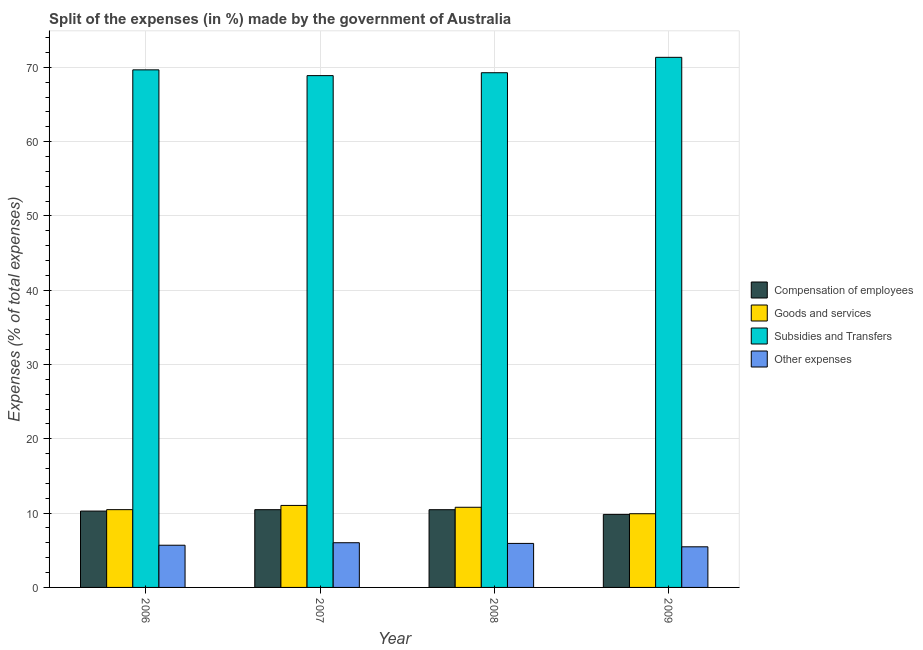How many groups of bars are there?
Offer a very short reply. 4. Are the number of bars per tick equal to the number of legend labels?
Offer a terse response. Yes. How many bars are there on the 2nd tick from the left?
Provide a succinct answer. 4. How many bars are there on the 3rd tick from the right?
Offer a very short reply. 4. In how many cases, is the number of bars for a given year not equal to the number of legend labels?
Your answer should be very brief. 0. What is the percentage of amount spent on subsidies in 2007?
Your answer should be compact. 68.88. Across all years, what is the maximum percentage of amount spent on subsidies?
Keep it short and to the point. 71.34. Across all years, what is the minimum percentage of amount spent on subsidies?
Make the answer very short. 68.88. In which year was the percentage of amount spent on goods and services maximum?
Provide a succinct answer. 2007. What is the total percentage of amount spent on subsidies in the graph?
Your answer should be very brief. 279.14. What is the difference between the percentage of amount spent on compensation of employees in 2007 and that in 2009?
Your response must be concise. 0.64. What is the difference between the percentage of amount spent on goods and services in 2007 and the percentage of amount spent on compensation of employees in 2006?
Your response must be concise. 0.57. What is the average percentage of amount spent on goods and services per year?
Provide a short and direct response. 10.55. What is the ratio of the percentage of amount spent on subsidies in 2007 to that in 2009?
Offer a terse response. 0.97. What is the difference between the highest and the second highest percentage of amount spent on subsidies?
Provide a succinct answer. 1.69. What is the difference between the highest and the lowest percentage of amount spent on goods and services?
Your answer should be compact. 1.12. Is it the case that in every year, the sum of the percentage of amount spent on goods and services and percentage of amount spent on subsidies is greater than the sum of percentage of amount spent on compensation of employees and percentage of amount spent on other expenses?
Make the answer very short. No. What does the 3rd bar from the left in 2006 represents?
Ensure brevity in your answer.  Subsidies and Transfers. What does the 2nd bar from the right in 2009 represents?
Offer a terse response. Subsidies and Transfers. Does the graph contain any zero values?
Give a very brief answer. No. What is the title of the graph?
Offer a very short reply. Split of the expenses (in %) made by the government of Australia. Does "Fourth 20% of population" appear as one of the legend labels in the graph?
Ensure brevity in your answer.  No. What is the label or title of the Y-axis?
Offer a very short reply. Expenses (% of total expenses). What is the Expenses (% of total expenses) in Compensation of employees in 2006?
Make the answer very short. 10.28. What is the Expenses (% of total expenses) of Goods and services in 2006?
Provide a short and direct response. 10.47. What is the Expenses (% of total expenses) in Subsidies and Transfers in 2006?
Provide a short and direct response. 69.65. What is the Expenses (% of total expenses) in Other expenses in 2006?
Provide a succinct answer. 5.68. What is the Expenses (% of total expenses) of Compensation of employees in 2007?
Provide a short and direct response. 10.46. What is the Expenses (% of total expenses) of Goods and services in 2007?
Your answer should be compact. 11.03. What is the Expenses (% of total expenses) of Subsidies and Transfers in 2007?
Your response must be concise. 68.88. What is the Expenses (% of total expenses) in Other expenses in 2007?
Make the answer very short. 6.02. What is the Expenses (% of total expenses) in Compensation of employees in 2008?
Ensure brevity in your answer.  10.46. What is the Expenses (% of total expenses) in Goods and services in 2008?
Provide a short and direct response. 10.79. What is the Expenses (% of total expenses) in Subsidies and Transfers in 2008?
Offer a very short reply. 69.27. What is the Expenses (% of total expenses) of Other expenses in 2008?
Give a very brief answer. 5.92. What is the Expenses (% of total expenses) of Compensation of employees in 2009?
Ensure brevity in your answer.  9.83. What is the Expenses (% of total expenses) in Goods and services in 2009?
Your answer should be compact. 9.92. What is the Expenses (% of total expenses) in Subsidies and Transfers in 2009?
Provide a succinct answer. 71.34. What is the Expenses (% of total expenses) in Other expenses in 2009?
Offer a very short reply. 5.47. Across all years, what is the maximum Expenses (% of total expenses) of Compensation of employees?
Provide a short and direct response. 10.46. Across all years, what is the maximum Expenses (% of total expenses) of Goods and services?
Your answer should be very brief. 11.03. Across all years, what is the maximum Expenses (% of total expenses) of Subsidies and Transfers?
Your answer should be compact. 71.34. Across all years, what is the maximum Expenses (% of total expenses) of Other expenses?
Make the answer very short. 6.02. Across all years, what is the minimum Expenses (% of total expenses) in Compensation of employees?
Make the answer very short. 9.83. Across all years, what is the minimum Expenses (% of total expenses) in Goods and services?
Your answer should be very brief. 9.92. Across all years, what is the minimum Expenses (% of total expenses) in Subsidies and Transfers?
Offer a terse response. 68.88. Across all years, what is the minimum Expenses (% of total expenses) of Other expenses?
Provide a succinct answer. 5.47. What is the total Expenses (% of total expenses) of Compensation of employees in the graph?
Your answer should be compact. 41.03. What is the total Expenses (% of total expenses) of Goods and services in the graph?
Offer a very short reply. 42.21. What is the total Expenses (% of total expenses) of Subsidies and Transfers in the graph?
Offer a terse response. 279.14. What is the total Expenses (% of total expenses) in Other expenses in the graph?
Your answer should be very brief. 23.08. What is the difference between the Expenses (% of total expenses) in Compensation of employees in 2006 and that in 2007?
Your response must be concise. -0.19. What is the difference between the Expenses (% of total expenses) of Goods and services in 2006 and that in 2007?
Your answer should be very brief. -0.57. What is the difference between the Expenses (% of total expenses) in Subsidies and Transfers in 2006 and that in 2007?
Give a very brief answer. 0.78. What is the difference between the Expenses (% of total expenses) of Other expenses in 2006 and that in 2007?
Your answer should be compact. -0.34. What is the difference between the Expenses (% of total expenses) of Compensation of employees in 2006 and that in 2008?
Make the answer very short. -0.19. What is the difference between the Expenses (% of total expenses) of Goods and services in 2006 and that in 2008?
Keep it short and to the point. -0.32. What is the difference between the Expenses (% of total expenses) of Subsidies and Transfers in 2006 and that in 2008?
Offer a very short reply. 0.39. What is the difference between the Expenses (% of total expenses) of Other expenses in 2006 and that in 2008?
Ensure brevity in your answer.  -0.24. What is the difference between the Expenses (% of total expenses) in Compensation of employees in 2006 and that in 2009?
Provide a succinct answer. 0.45. What is the difference between the Expenses (% of total expenses) in Goods and services in 2006 and that in 2009?
Your answer should be compact. 0.55. What is the difference between the Expenses (% of total expenses) in Subsidies and Transfers in 2006 and that in 2009?
Your answer should be very brief. -1.69. What is the difference between the Expenses (% of total expenses) of Other expenses in 2006 and that in 2009?
Offer a terse response. 0.21. What is the difference between the Expenses (% of total expenses) in Compensation of employees in 2007 and that in 2008?
Provide a succinct answer. 0. What is the difference between the Expenses (% of total expenses) of Goods and services in 2007 and that in 2008?
Give a very brief answer. 0.25. What is the difference between the Expenses (% of total expenses) of Subsidies and Transfers in 2007 and that in 2008?
Make the answer very short. -0.39. What is the difference between the Expenses (% of total expenses) in Other expenses in 2007 and that in 2008?
Offer a terse response. 0.09. What is the difference between the Expenses (% of total expenses) of Compensation of employees in 2007 and that in 2009?
Ensure brevity in your answer.  0.64. What is the difference between the Expenses (% of total expenses) in Goods and services in 2007 and that in 2009?
Your answer should be very brief. 1.12. What is the difference between the Expenses (% of total expenses) in Subsidies and Transfers in 2007 and that in 2009?
Provide a short and direct response. -2.46. What is the difference between the Expenses (% of total expenses) of Other expenses in 2007 and that in 2009?
Your response must be concise. 0.55. What is the difference between the Expenses (% of total expenses) of Compensation of employees in 2008 and that in 2009?
Give a very brief answer. 0.63. What is the difference between the Expenses (% of total expenses) of Goods and services in 2008 and that in 2009?
Give a very brief answer. 0.87. What is the difference between the Expenses (% of total expenses) of Subsidies and Transfers in 2008 and that in 2009?
Offer a very short reply. -2.07. What is the difference between the Expenses (% of total expenses) of Other expenses in 2008 and that in 2009?
Keep it short and to the point. 0.46. What is the difference between the Expenses (% of total expenses) of Compensation of employees in 2006 and the Expenses (% of total expenses) of Goods and services in 2007?
Your response must be concise. -0.76. What is the difference between the Expenses (% of total expenses) in Compensation of employees in 2006 and the Expenses (% of total expenses) in Subsidies and Transfers in 2007?
Your answer should be compact. -58.6. What is the difference between the Expenses (% of total expenses) in Compensation of employees in 2006 and the Expenses (% of total expenses) in Other expenses in 2007?
Keep it short and to the point. 4.26. What is the difference between the Expenses (% of total expenses) in Goods and services in 2006 and the Expenses (% of total expenses) in Subsidies and Transfers in 2007?
Your response must be concise. -58.41. What is the difference between the Expenses (% of total expenses) in Goods and services in 2006 and the Expenses (% of total expenses) in Other expenses in 2007?
Offer a terse response. 4.45. What is the difference between the Expenses (% of total expenses) in Subsidies and Transfers in 2006 and the Expenses (% of total expenses) in Other expenses in 2007?
Your response must be concise. 63.64. What is the difference between the Expenses (% of total expenses) of Compensation of employees in 2006 and the Expenses (% of total expenses) of Goods and services in 2008?
Keep it short and to the point. -0.51. What is the difference between the Expenses (% of total expenses) of Compensation of employees in 2006 and the Expenses (% of total expenses) of Subsidies and Transfers in 2008?
Ensure brevity in your answer.  -58.99. What is the difference between the Expenses (% of total expenses) in Compensation of employees in 2006 and the Expenses (% of total expenses) in Other expenses in 2008?
Provide a succinct answer. 4.35. What is the difference between the Expenses (% of total expenses) in Goods and services in 2006 and the Expenses (% of total expenses) in Subsidies and Transfers in 2008?
Your answer should be compact. -58.8. What is the difference between the Expenses (% of total expenses) in Goods and services in 2006 and the Expenses (% of total expenses) in Other expenses in 2008?
Offer a terse response. 4.54. What is the difference between the Expenses (% of total expenses) in Subsidies and Transfers in 2006 and the Expenses (% of total expenses) in Other expenses in 2008?
Ensure brevity in your answer.  63.73. What is the difference between the Expenses (% of total expenses) of Compensation of employees in 2006 and the Expenses (% of total expenses) of Goods and services in 2009?
Ensure brevity in your answer.  0.36. What is the difference between the Expenses (% of total expenses) in Compensation of employees in 2006 and the Expenses (% of total expenses) in Subsidies and Transfers in 2009?
Make the answer very short. -61.06. What is the difference between the Expenses (% of total expenses) in Compensation of employees in 2006 and the Expenses (% of total expenses) in Other expenses in 2009?
Offer a very short reply. 4.81. What is the difference between the Expenses (% of total expenses) of Goods and services in 2006 and the Expenses (% of total expenses) of Subsidies and Transfers in 2009?
Ensure brevity in your answer.  -60.87. What is the difference between the Expenses (% of total expenses) of Goods and services in 2006 and the Expenses (% of total expenses) of Other expenses in 2009?
Ensure brevity in your answer.  5. What is the difference between the Expenses (% of total expenses) of Subsidies and Transfers in 2006 and the Expenses (% of total expenses) of Other expenses in 2009?
Your answer should be very brief. 64.19. What is the difference between the Expenses (% of total expenses) in Compensation of employees in 2007 and the Expenses (% of total expenses) in Goods and services in 2008?
Provide a short and direct response. -0.32. What is the difference between the Expenses (% of total expenses) of Compensation of employees in 2007 and the Expenses (% of total expenses) of Subsidies and Transfers in 2008?
Offer a terse response. -58.8. What is the difference between the Expenses (% of total expenses) in Compensation of employees in 2007 and the Expenses (% of total expenses) in Other expenses in 2008?
Ensure brevity in your answer.  4.54. What is the difference between the Expenses (% of total expenses) of Goods and services in 2007 and the Expenses (% of total expenses) of Subsidies and Transfers in 2008?
Keep it short and to the point. -58.23. What is the difference between the Expenses (% of total expenses) of Goods and services in 2007 and the Expenses (% of total expenses) of Other expenses in 2008?
Give a very brief answer. 5.11. What is the difference between the Expenses (% of total expenses) in Subsidies and Transfers in 2007 and the Expenses (% of total expenses) in Other expenses in 2008?
Give a very brief answer. 62.95. What is the difference between the Expenses (% of total expenses) in Compensation of employees in 2007 and the Expenses (% of total expenses) in Goods and services in 2009?
Keep it short and to the point. 0.55. What is the difference between the Expenses (% of total expenses) in Compensation of employees in 2007 and the Expenses (% of total expenses) in Subsidies and Transfers in 2009?
Your answer should be compact. -60.88. What is the difference between the Expenses (% of total expenses) of Compensation of employees in 2007 and the Expenses (% of total expenses) of Other expenses in 2009?
Offer a very short reply. 5. What is the difference between the Expenses (% of total expenses) in Goods and services in 2007 and the Expenses (% of total expenses) in Subsidies and Transfers in 2009?
Keep it short and to the point. -60.31. What is the difference between the Expenses (% of total expenses) of Goods and services in 2007 and the Expenses (% of total expenses) of Other expenses in 2009?
Ensure brevity in your answer.  5.57. What is the difference between the Expenses (% of total expenses) of Subsidies and Transfers in 2007 and the Expenses (% of total expenses) of Other expenses in 2009?
Your answer should be very brief. 63.41. What is the difference between the Expenses (% of total expenses) of Compensation of employees in 2008 and the Expenses (% of total expenses) of Goods and services in 2009?
Make the answer very short. 0.54. What is the difference between the Expenses (% of total expenses) in Compensation of employees in 2008 and the Expenses (% of total expenses) in Subsidies and Transfers in 2009?
Your response must be concise. -60.88. What is the difference between the Expenses (% of total expenses) in Compensation of employees in 2008 and the Expenses (% of total expenses) in Other expenses in 2009?
Make the answer very short. 4.99. What is the difference between the Expenses (% of total expenses) of Goods and services in 2008 and the Expenses (% of total expenses) of Subsidies and Transfers in 2009?
Ensure brevity in your answer.  -60.55. What is the difference between the Expenses (% of total expenses) in Goods and services in 2008 and the Expenses (% of total expenses) in Other expenses in 2009?
Offer a very short reply. 5.32. What is the difference between the Expenses (% of total expenses) of Subsidies and Transfers in 2008 and the Expenses (% of total expenses) of Other expenses in 2009?
Keep it short and to the point. 63.8. What is the average Expenses (% of total expenses) in Compensation of employees per year?
Offer a very short reply. 10.26. What is the average Expenses (% of total expenses) in Goods and services per year?
Make the answer very short. 10.55. What is the average Expenses (% of total expenses) in Subsidies and Transfers per year?
Provide a succinct answer. 69.78. What is the average Expenses (% of total expenses) in Other expenses per year?
Offer a very short reply. 5.77. In the year 2006, what is the difference between the Expenses (% of total expenses) in Compensation of employees and Expenses (% of total expenses) in Goods and services?
Your answer should be very brief. -0.19. In the year 2006, what is the difference between the Expenses (% of total expenses) of Compensation of employees and Expenses (% of total expenses) of Subsidies and Transfers?
Keep it short and to the point. -59.38. In the year 2006, what is the difference between the Expenses (% of total expenses) of Compensation of employees and Expenses (% of total expenses) of Other expenses?
Keep it short and to the point. 4.6. In the year 2006, what is the difference between the Expenses (% of total expenses) in Goods and services and Expenses (% of total expenses) in Subsidies and Transfers?
Give a very brief answer. -59.19. In the year 2006, what is the difference between the Expenses (% of total expenses) in Goods and services and Expenses (% of total expenses) in Other expenses?
Your response must be concise. 4.79. In the year 2006, what is the difference between the Expenses (% of total expenses) of Subsidies and Transfers and Expenses (% of total expenses) of Other expenses?
Provide a short and direct response. 63.98. In the year 2007, what is the difference between the Expenses (% of total expenses) of Compensation of employees and Expenses (% of total expenses) of Goods and services?
Ensure brevity in your answer.  -0.57. In the year 2007, what is the difference between the Expenses (% of total expenses) of Compensation of employees and Expenses (% of total expenses) of Subsidies and Transfers?
Provide a succinct answer. -58.41. In the year 2007, what is the difference between the Expenses (% of total expenses) of Compensation of employees and Expenses (% of total expenses) of Other expenses?
Your response must be concise. 4.45. In the year 2007, what is the difference between the Expenses (% of total expenses) in Goods and services and Expenses (% of total expenses) in Subsidies and Transfers?
Make the answer very short. -57.84. In the year 2007, what is the difference between the Expenses (% of total expenses) in Goods and services and Expenses (% of total expenses) in Other expenses?
Offer a very short reply. 5.02. In the year 2007, what is the difference between the Expenses (% of total expenses) in Subsidies and Transfers and Expenses (% of total expenses) in Other expenses?
Give a very brief answer. 62.86. In the year 2008, what is the difference between the Expenses (% of total expenses) of Compensation of employees and Expenses (% of total expenses) of Goods and services?
Give a very brief answer. -0.33. In the year 2008, what is the difference between the Expenses (% of total expenses) in Compensation of employees and Expenses (% of total expenses) in Subsidies and Transfers?
Keep it short and to the point. -58.81. In the year 2008, what is the difference between the Expenses (% of total expenses) of Compensation of employees and Expenses (% of total expenses) of Other expenses?
Give a very brief answer. 4.54. In the year 2008, what is the difference between the Expenses (% of total expenses) of Goods and services and Expenses (% of total expenses) of Subsidies and Transfers?
Provide a short and direct response. -58.48. In the year 2008, what is the difference between the Expenses (% of total expenses) in Goods and services and Expenses (% of total expenses) in Other expenses?
Ensure brevity in your answer.  4.86. In the year 2008, what is the difference between the Expenses (% of total expenses) in Subsidies and Transfers and Expenses (% of total expenses) in Other expenses?
Your answer should be compact. 63.34. In the year 2009, what is the difference between the Expenses (% of total expenses) of Compensation of employees and Expenses (% of total expenses) of Goods and services?
Provide a succinct answer. -0.09. In the year 2009, what is the difference between the Expenses (% of total expenses) in Compensation of employees and Expenses (% of total expenses) in Subsidies and Transfers?
Your response must be concise. -61.51. In the year 2009, what is the difference between the Expenses (% of total expenses) in Compensation of employees and Expenses (% of total expenses) in Other expenses?
Your answer should be compact. 4.36. In the year 2009, what is the difference between the Expenses (% of total expenses) of Goods and services and Expenses (% of total expenses) of Subsidies and Transfers?
Offer a terse response. -61.42. In the year 2009, what is the difference between the Expenses (% of total expenses) of Goods and services and Expenses (% of total expenses) of Other expenses?
Your response must be concise. 4.45. In the year 2009, what is the difference between the Expenses (% of total expenses) in Subsidies and Transfers and Expenses (% of total expenses) in Other expenses?
Make the answer very short. 65.87. What is the ratio of the Expenses (% of total expenses) in Compensation of employees in 2006 to that in 2007?
Provide a succinct answer. 0.98. What is the ratio of the Expenses (% of total expenses) of Goods and services in 2006 to that in 2007?
Ensure brevity in your answer.  0.95. What is the ratio of the Expenses (% of total expenses) in Subsidies and Transfers in 2006 to that in 2007?
Your response must be concise. 1.01. What is the ratio of the Expenses (% of total expenses) in Other expenses in 2006 to that in 2007?
Ensure brevity in your answer.  0.94. What is the ratio of the Expenses (% of total expenses) of Compensation of employees in 2006 to that in 2008?
Your answer should be compact. 0.98. What is the ratio of the Expenses (% of total expenses) of Goods and services in 2006 to that in 2008?
Ensure brevity in your answer.  0.97. What is the ratio of the Expenses (% of total expenses) in Subsidies and Transfers in 2006 to that in 2008?
Keep it short and to the point. 1.01. What is the ratio of the Expenses (% of total expenses) in Other expenses in 2006 to that in 2008?
Keep it short and to the point. 0.96. What is the ratio of the Expenses (% of total expenses) in Compensation of employees in 2006 to that in 2009?
Ensure brevity in your answer.  1.05. What is the ratio of the Expenses (% of total expenses) in Goods and services in 2006 to that in 2009?
Your answer should be very brief. 1.06. What is the ratio of the Expenses (% of total expenses) in Subsidies and Transfers in 2006 to that in 2009?
Make the answer very short. 0.98. What is the ratio of the Expenses (% of total expenses) in Other expenses in 2006 to that in 2009?
Your answer should be very brief. 1.04. What is the ratio of the Expenses (% of total expenses) of Goods and services in 2007 to that in 2008?
Offer a very short reply. 1.02. What is the ratio of the Expenses (% of total expenses) in Subsidies and Transfers in 2007 to that in 2008?
Your response must be concise. 0.99. What is the ratio of the Expenses (% of total expenses) of Other expenses in 2007 to that in 2008?
Your response must be concise. 1.02. What is the ratio of the Expenses (% of total expenses) of Compensation of employees in 2007 to that in 2009?
Offer a terse response. 1.06. What is the ratio of the Expenses (% of total expenses) of Goods and services in 2007 to that in 2009?
Your answer should be very brief. 1.11. What is the ratio of the Expenses (% of total expenses) of Subsidies and Transfers in 2007 to that in 2009?
Offer a terse response. 0.97. What is the ratio of the Expenses (% of total expenses) of Other expenses in 2007 to that in 2009?
Provide a succinct answer. 1.1. What is the ratio of the Expenses (% of total expenses) in Compensation of employees in 2008 to that in 2009?
Ensure brevity in your answer.  1.06. What is the ratio of the Expenses (% of total expenses) in Goods and services in 2008 to that in 2009?
Provide a short and direct response. 1.09. What is the ratio of the Expenses (% of total expenses) in Subsidies and Transfers in 2008 to that in 2009?
Offer a terse response. 0.97. What is the ratio of the Expenses (% of total expenses) of Other expenses in 2008 to that in 2009?
Ensure brevity in your answer.  1.08. What is the difference between the highest and the second highest Expenses (% of total expenses) in Compensation of employees?
Your answer should be very brief. 0. What is the difference between the highest and the second highest Expenses (% of total expenses) of Goods and services?
Your answer should be very brief. 0.25. What is the difference between the highest and the second highest Expenses (% of total expenses) in Subsidies and Transfers?
Give a very brief answer. 1.69. What is the difference between the highest and the second highest Expenses (% of total expenses) in Other expenses?
Offer a very short reply. 0.09. What is the difference between the highest and the lowest Expenses (% of total expenses) in Compensation of employees?
Provide a succinct answer. 0.64. What is the difference between the highest and the lowest Expenses (% of total expenses) in Goods and services?
Provide a short and direct response. 1.12. What is the difference between the highest and the lowest Expenses (% of total expenses) in Subsidies and Transfers?
Keep it short and to the point. 2.46. What is the difference between the highest and the lowest Expenses (% of total expenses) in Other expenses?
Your answer should be compact. 0.55. 